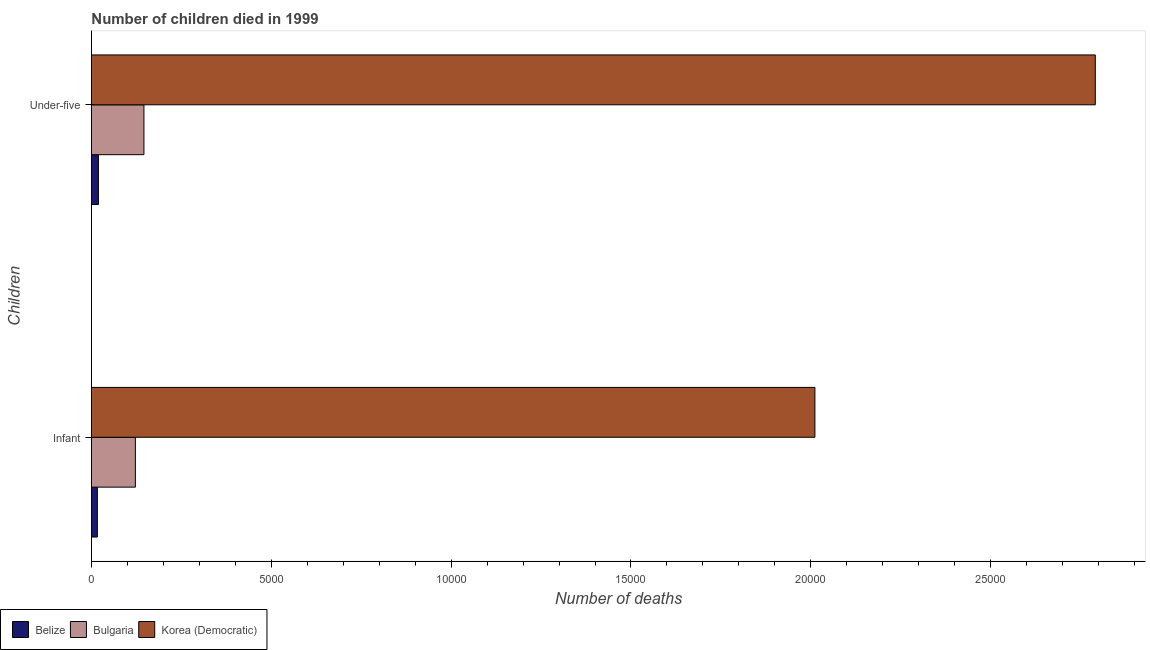How many different coloured bars are there?
Your answer should be compact. 3. Are the number of bars per tick equal to the number of legend labels?
Provide a short and direct response. Yes. How many bars are there on the 1st tick from the bottom?
Your answer should be very brief. 3. What is the label of the 2nd group of bars from the top?
Provide a succinct answer. Infant. What is the number of under-five deaths in Belize?
Offer a very short reply. 195. Across all countries, what is the maximum number of infant deaths?
Give a very brief answer. 2.01e+04. Across all countries, what is the minimum number of infant deaths?
Provide a short and direct response. 165. In which country was the number of infant deaths maximum?
Your answer should be compact. Korea (Democratic). In which country was the number of under-five deaths minimum?
Keep it short and to the point. Belize. What is the total number of infant deaths in the graph?
Make the answer very short. 2.15e+04. What is the difference between the number of infant deaths in Korea (Democratic) and that in Bulgaria?
Your answer should be compact. 1.89e+04. What is the difference between the number of under-five deaths in Belize and the number of infant deaths in Korea (Democratic)?
Keep it short and to the point. -1.99e+04. What is the average number of infant deaths per country?
Offer a terse response. 7166.67. What is the difference between the number of infant deaths and number of under-five deaths in Belize?
Offer a very short reply. -30. What is the ratio of the number of under-five deaths in Korea (Democratic) to that in Bulgaria?
Make the answer very short. 19.12. Is the number of infant deaths in Bulgaria less than that in Belize?
Give a very brief answer. No. In how many countries, is the number of under-five deaths greater than the average number of under-five deaths taken over all countries?
Give a very brief answer. 1. What does the 2nd bar from the top in Infant represents?
Keep it short and to the point. Bulgaria. What does the 2nd bar from the bottom in Under-five represents?
Your answer should be very brief. Bulgaria. How many bars are there?
Your answer should be compact. 6. How many countries are there in the graph?
Ensure brevity in your answer.  3. Does the graph contain any zero values?
Offer a very short reply. No. Does the graph contain grids?
Your answer should be compact. No. Where does the legend appear in the graph?
Offer a terse response. Bottom left. What is the title of the graph?
Give a very brief answer. Number of children died in 1999. What is the label or title of the X-axis?
Provide a short and direct response. Number of deaths. What is the label or title of the Y-axis?
Provide a succinct answer. Children. What is the Number of deaths of Belize in Infant?
Your answer should be compact. 165. What is the Number of deaths of Bulgaria in Infant?
Your answer should be compact. 1222. What is the Number of deaths in Korea (Democratic) in Infant?
Your answer should be compact. 2.01e+04. What is the Number of deaths of Belize in Under-five?
Provide a short and direct response. 195. What is the Number of deaths of Bulgaria in Under-five?
Offer a terse response. 1460. What is the Number of deaths in Korea (Democratic) in Under-five?
Give a very brief answer. 2.79e+04. Across all Children, what is the maximum Number of deaths of Belize?
Give a very brief answer. 195. Across all Children, what is the maximum Number of deaths of Bulgaria?
Offer a very short reply. 1460. Across all Children, what is the maximum Number of deaths of Korea (Democratic)?
Give a very brief answer. 2.79e+04. Across all Children, what is the minimum Number of deaths in Belize?
Ensure brevity in your answer.  165. Across all Children, what is the minimum Number of deaths in Bulgaria?
Offer a very short reply. 1222. Across all Children, what is the minimum Number of deaths in Korea (Democratic)?
Offer a very short reply. 2.01e+04. What is the total Number of deaths of Belize in the graph?
Your answer should be compact. 360. What is the total Number of deaths of Bulgaria in the graph?
Offer a very short reply. 2682. What is the total Number of deaths in Korea (Democratic) in the graph?
Make the answer very short. 4.80e+04. What is the difference between the Number of deaths of Belize in Infant and that in Under-five?
Give a very brief answer. -30. What is the difference between the Number of deaths in Bulgaria in Infant and that in Under-five?
Give a very brief answer. -238. What is the difference between the Number of deaths of Korea (Democratic) in Infant and that in Under-five?
Ensure brevity in your answer.  -7795. What is the difference between the Number of deaths of Belize in Infant and the Number of deaths of Bulgaria in Under-five?
Provide a short and direct response. -1295. What is the difference between the Number of deaths in Belize in Infant and the Number of deaths in Korea (Democratic) in Under-five?
Ensure brevity in your answer.  -2.77e+04. What is the difference between the Number of deaths in Bulgaria in Infant and the Number of deaths in Korea (Democratic) in Under-five?
Keep it short and to the point. -2.67e+04. What is the average Number of deaths in Belize per Children?
Offer a terse response. 180. What is the average Number of deaths of Bulgaria per Children?
Provide a succinct answer. 1341. What is the average Number of deaths in Korea (Democratic) per Children?
Make the answer very short. 2.40e+04. What is the difference between the Number of deaths of Belize and Number of deaths of Bulgaria in Infant?
Your answer should be compact. -1057. What is the difference between the Number of deaths of Belize and Number of deaths of Korea (Democratic) in Infant?
Keep it short and to the point. -1.99e+04. What is the difference between the Number of deaths in Bulgaria and Number of deaths in Korea (Democratic) in Infant?
Your response must be concise. -1.89e+04. What is the difference between the Number of deaths in Belize and Number of deaths in Bulgaria in Under-five?
Offer a very short reply. -1265. What is the difference between the Number of deaths of Belize and Number of deaths of Korea (Democratic) in Under-five?
Your answer should be very brief. -2.77e+04. What is the difference between the Number of deaths of Bulgaria and Number of deaths of Korea (Democratic) in Under-five?
Make the answer very short. -2.64e+04. What is the ratio of the Number of deaths of Belize in Infant to that in Under-five?
Ensure brevity in your answer.  0.85. What is the ratio of the Number of deaths of Bulgaria in Infant to that in Under-five?
Offer a terse response. 0.84. What is the ratio of the Number of deaths in Korea (Democratic) in Infant to that in Under-five?
Make the answer very short. 0.72. What is the difference between the highest and the second highest Number of deaths in Bulgaria?
Offer a very short reply. 238. What is the difference between the highest and the second highest Number of deaths in Korea (Democratic)?
Your answer should be compact. 7795. What is the difference between the highest and the lowest Number of deaths in Bulgaria?
Your answer should be very brief. 238. What is the difference between the highest and the lowest Number of deaths in Korea (Democratic)?
Offer a terse response. 7795. 